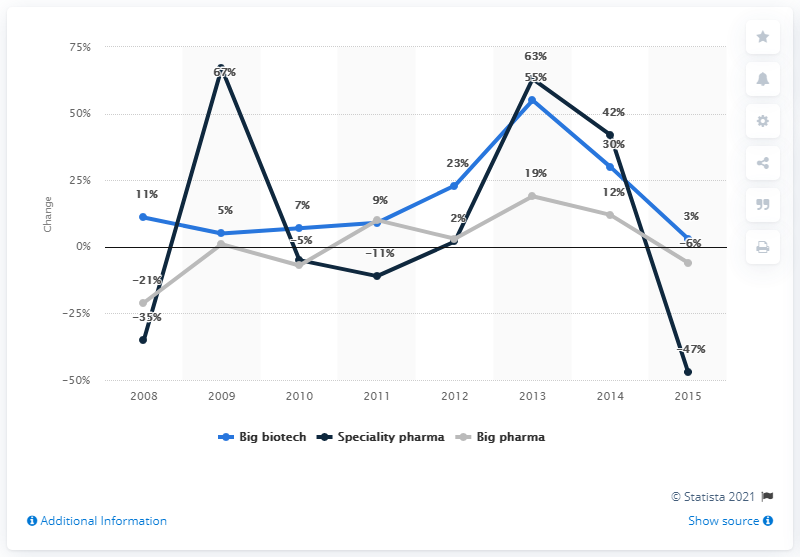Give some essential details in this illustration. In 2012, the big biotech segment experienced significant growth. Specifically, the growth was 23... 